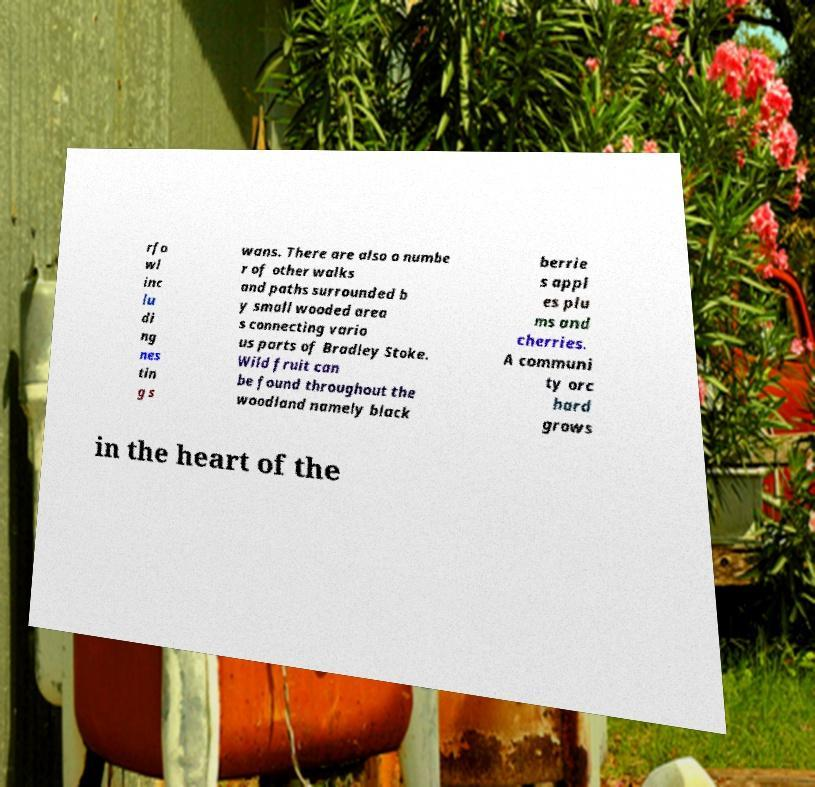Could you extract and type out the text from this image? rfo wl inc lu di ng nes tin g s wans. There are also a numbe r of other walks and paths surrounded b y small wooded area s connecting vario us parts of Bradley Stoke. Wild fruit can be found throughout the woodland namely black berrie s appl es plu ms and cherries. A communi ty orc hard grows in the heart of the 